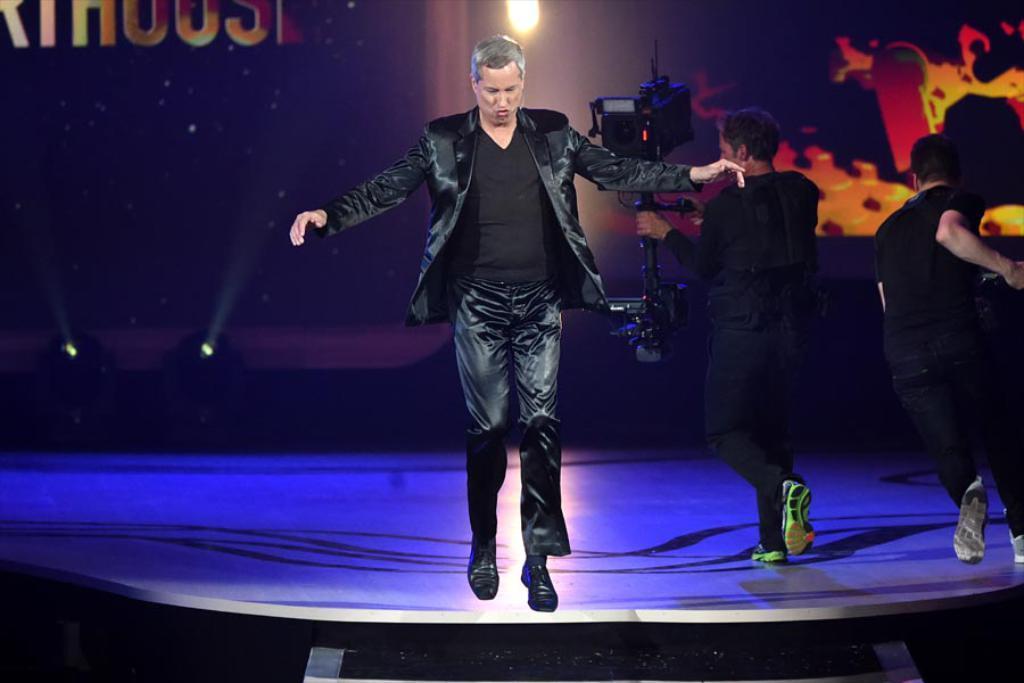In one or two sentences, can you explain what this image depicts? This picture shows a man jumping and we see a man holding a camera and walking and we see a another man running. 